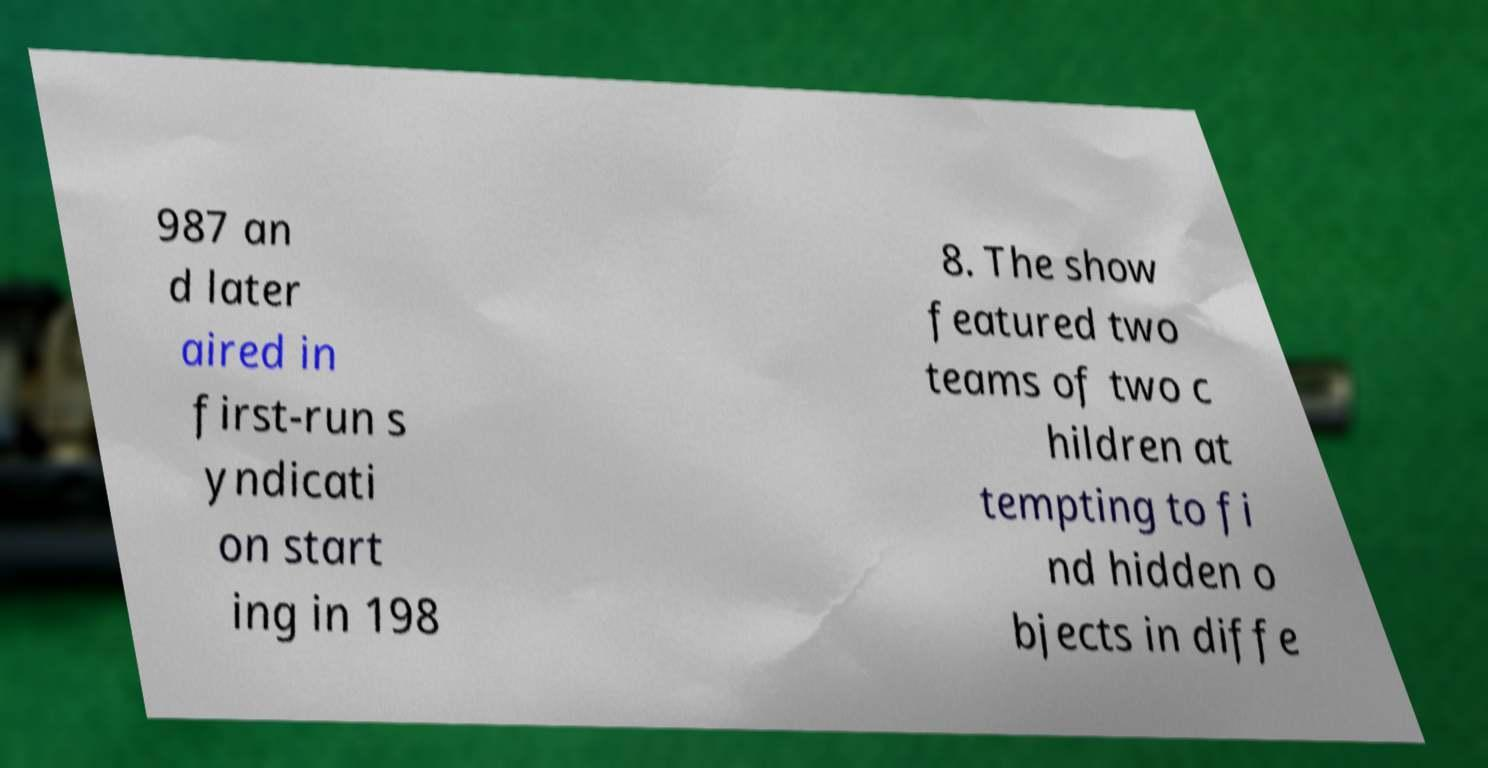There's text embedded in this image that I need extracted. Can you transcribe it verbatim? 987 an d later aired in first-run s yndicati on start ing in 198 8. The show featured two teams of two c hildren at tempting to fi nd hidden o bjects in diffe 